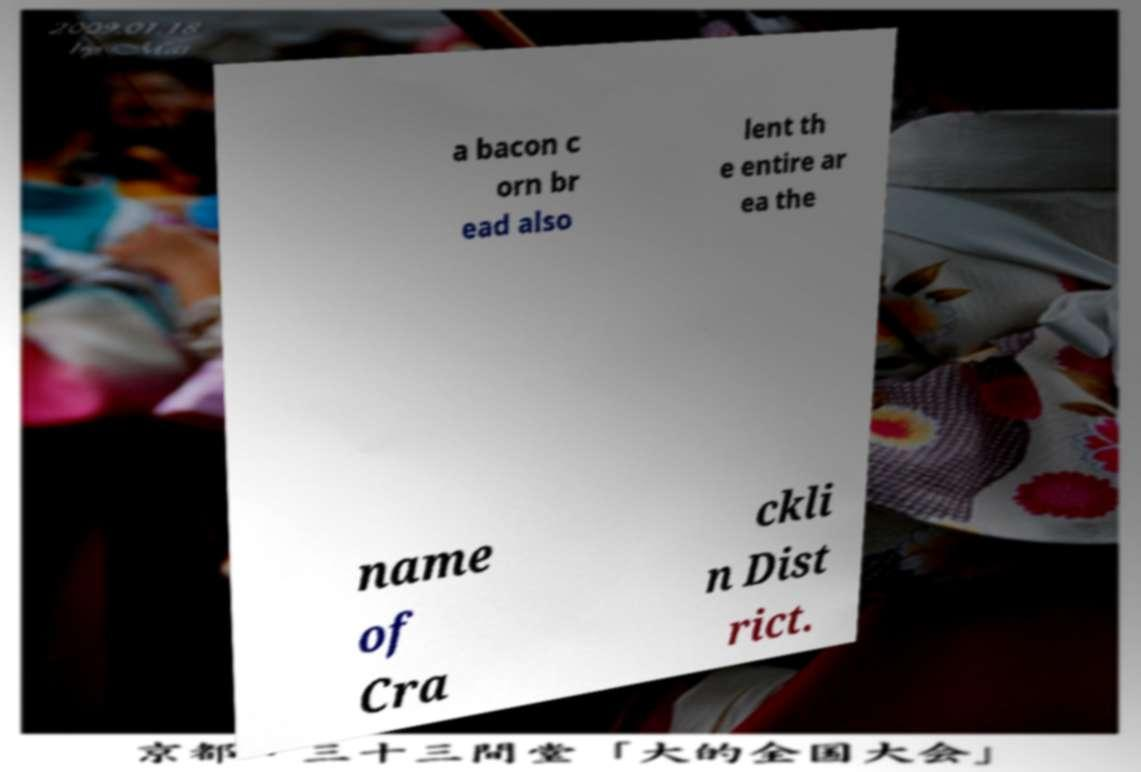What messages or text are displayed in this image? I need them in a readable, typed format. a bacon c orn br ead also lent th e entire ar ea the name of Cra ckli n Dist rict. 